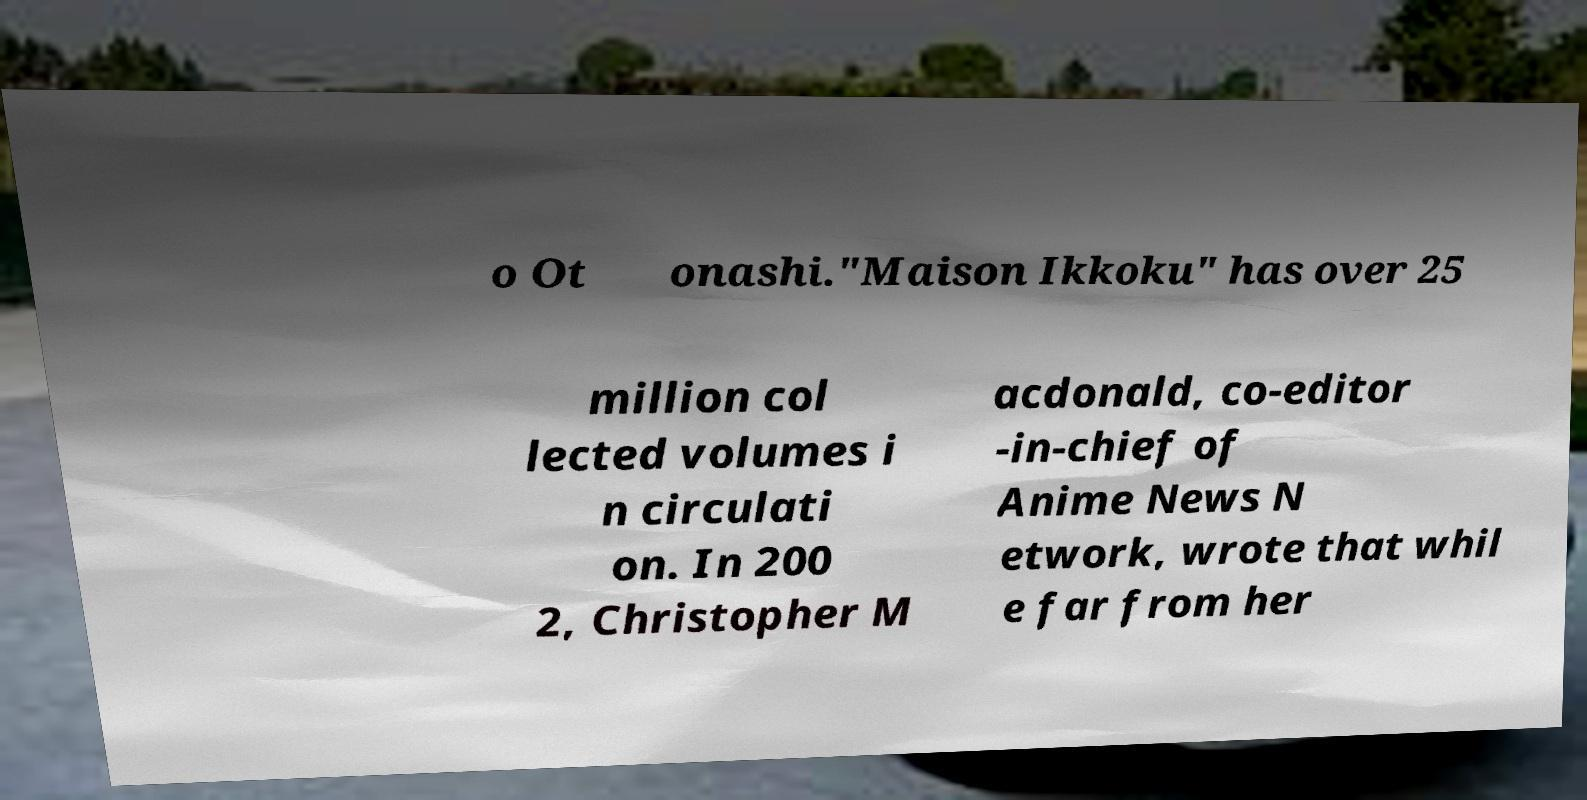For documentation purposes, I need the text within this image transcribed. Could you provide that? o Ot onashi."Maison Ikkoku" has over 25 million col lected volumes i n circulati on. In 200 2, Christopher M acdonald, co-editor -in-chief of Anime News N etwork, wrote that whil e far from her 